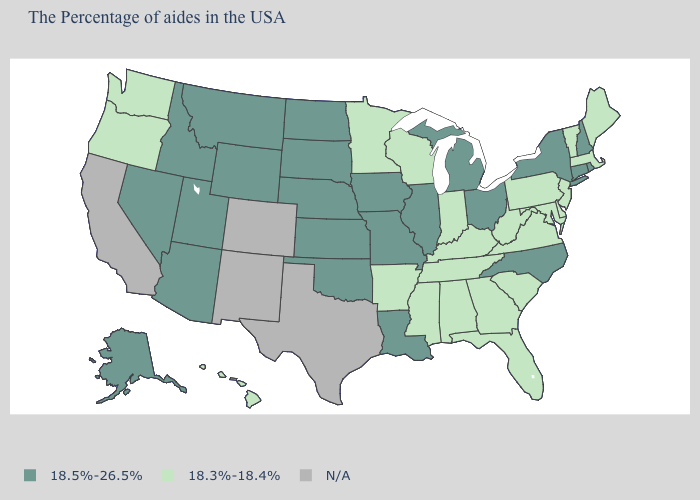Among the states that border Vermont , does New York have the highest value?
Short answer required. Yes. Name the states that have a value in the range 18.3%-18.4%?
Keep it brief. Maine, Massachusetts, Vermont, New Jersey, Delaware, Maryland, Pennsylvania, Virginia, South Carolina, West Virginia, Florida, Georgia, Kentucky, Indiana, Alabama, Tennessee, Wisconsin, Mississippi, Arkansas, Minnesota, Washington, Oregon, Hawaii. What is the value of North Carolina?
Answer briefly. 18.5%-26.5%. What is the value of Maryland?
Be succinct. 18.3%-18.4%. What is the value of Vermont?
Short answer required. 18.3%-18.4%. Is the legend a continuous bar?
Short answer required. No. Which states hav the highest value in the MidWest?
Keep it brief. Ohio, Michigan, Illinois, Missouri, Iowa, Kansas, Nebraska, South Dakota, North Dakota. Among the states that border Wyoming , which have the lowest value?
Be succinct. Nebraska, South Dakota, Utah, Montana, Idaho. What is the value of Rhode Island?
Quick response, please. 18.5%-26.5%. Among the states that border Kansas , which have the lowest value?
Give a very brief answer. Missouri, Nebraska, Oklahoma. What is the lowest value in the MidWest?
Give a very brief answer. 18.3%-18.4%. Does West Virginia have the lowest value in the USA?
Give a very brief answer. Yes. What is the value of North Carolina?
Concise answer only. 18.5%-26.5%. Which states hav the highest value in the MidWest?
Concise answer only. Ohio, Michigan, Illinois, Missouri, Iowa, Kansas, Nebraska, South Dakota, North Dakota. 